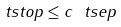Convert formula to latex. <formula><loc_0><loc_0><loc_500><loc_500>\ t s t o p \leq c \ t s e p</formula> 